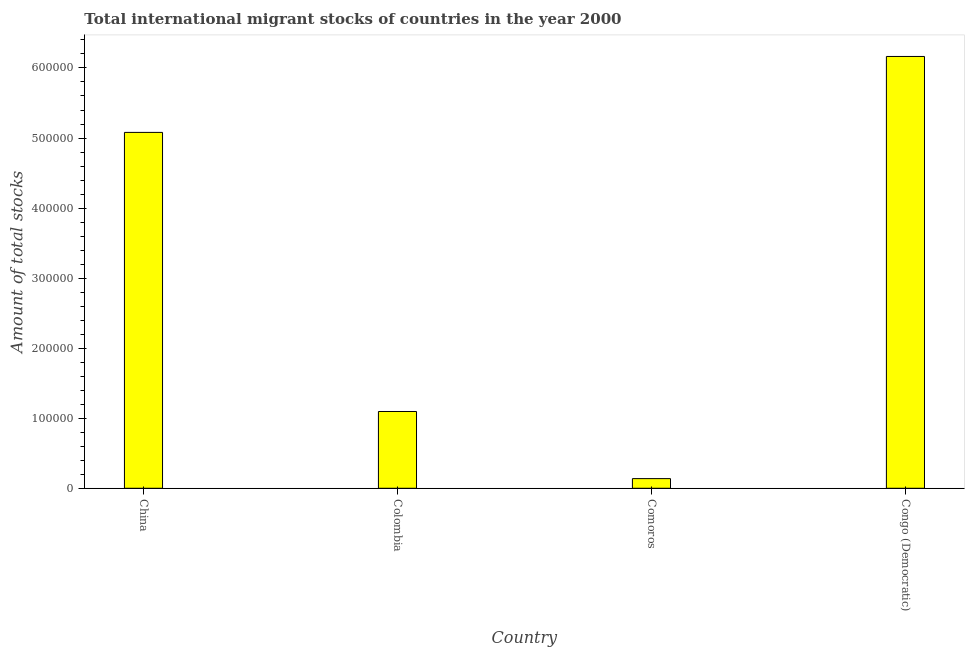Does the graph contain any zero values?
Make the answer very short. No. What is the title of the graph?
Provide a succinct answer. Total international migrant stocks of countries in the year 2000. What is the label or title of the Y-axis?
Offer a terse response. Amount of total stocks. What is the total number of international migrant stock in China?
Give a very brief answer. 5.08e+05. Across all countries, what is the maximum total number of international migrant stock?
Your answer should be very brief. 6.16e+05. Across all countries, what is the minimum total number of international migrant stock?
Your response must be concise. 1.38e+04. In which country was the total number of international migrant stock maximum?
Provide a succinct answer. Congo (Democratic). In which country was the total number of international migrant stock minimum?
Your answer should be very brief. Comoros. What is the sum of the total number of international migrant stock?
Your answer should be very brief. 1.25e+06. What is the difference between the total number of international migrant stock in China and Colombia?
Offer a terse response. 3.98e+05. What is the average total number of international migrant stock per country?
Provide a succinct answer. 3.12e+05. What is the median total number of international migrant stock?
Provide a succinct answer. 3.09e+05. What is the ratio of the total number of international migrant stock in China to that in Comoros?
Make the answer very short. 36.82. What is the difference between the highest and the second highest total number of international migrant stock?
Keep it short and to the point. 1.08e+05. What is the difference between the highest and the lowest total number of international migrant stock?
Keep it short and to the point. 6.03e+05. In how many countries, is the total number of international migrant stock greater than the average total number of international migrant stock taken over all countries?
Ensure brevity in your answer.  2. Are all the bars in the graph horizontal?
Provide a short and direct response. No. What is the difference between two consecutive major ticks on the Y-axis?
Your response must be concise. 1.00e+05. What is the Amount of total stocks of China?
Make the answer very short. 5.08e+05. What is the Amount of total stocks in Colombia?
Offer a very short reply. 1.10e+05. What is the Amount of total stocks in Comoros?
Provide a succinct answer. 1.38e+04. What is the Amount of total stocks in Congo (Democratic)?
Provide a short and direct response. 6.16e+05. What is the difference between the Amount of total stocks in China and Colombia?
Make the answer very short. 3.98e+05. What is the difference between the Amount of total stocks in China and Comoros?
Your answer should be very brief. 4.94e+05. What is the difference between the Amount of total stocks in China and Congo (Democratic)?
Your answer should be very brief. -1.08e+05. What is the difference between the Amount of total stocks in Colombia and Comoros?
Your answer should be very brief. 9.58e+04. What is the difference between the Amount of total stocks in Colombia and Congo (Democratic)?
Ensure brevity in your answer.  -5.07e+05. What is the difference between the Amount of total stocks in Comoros and Congo (Democratic)?
Your response must be concise. -6.03e+05. What is the ratio of the Amount of total stocks in China to that in Colombia?
Offer a terse response. 4.63. What is the ratio of the Amount of total stocks in China to that in Comoros?
Your answer should be compact. 36.82. What is the ratio of the Amount of total stocks in China to that in Congo (Democratic)?
Ensure brevity in your answer.  0.82. What is the ratio of the Amount of total stocks in Colombia to that in Comoros?
Ensure brevity in your answer.  7.94. What is the ratio of the Amount of total stocks in Colombia to that in Congo (Democratic)?
Offer a very short reply. 0.18. What is the ratio of the Amount of total stocks in Comoros to that in Congo (Democratic)?
Offer a very short reply. 0.02. 